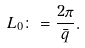<formula> <loc_0><loc_0><loc_500><loc_500>L _ { 0 } \colon = \frac { 2 \pi } { \bar { q } } .</formula> 